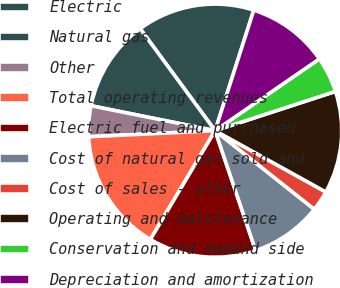Convert chart to OTSL. <chart><loc_0><loc_0><loc_500><loc_500><pie_chart><fcel>Electric<fcel>Natural gas<fcel>Other<fcel>Total operating revenues<fcel>Electric fuel and purchased<fcel>Cost of natural gas sold and<fcel>Cost of sales - other<fcel>Operating and maintenance<fcel>Conservation and demand side<fcel>Depreciation and amortization<nl><fcel>15.03%<fcel>11.76%<fcel>3.92%<fcel>15.69%<fcel>13.73%<fcel>9.15%<fcel>2.61%<fcel>13.07%<fcel>4.58%<fcel>10.46%<nl></chart> 